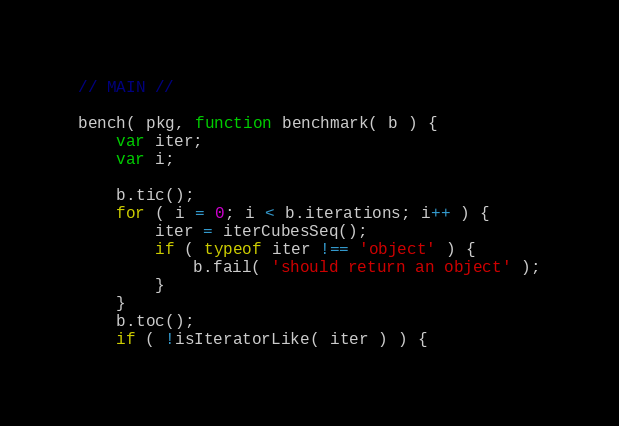<code> <loc_0><loc_0><loc_500><loc_500><_JavaScript_>

// MAIN //

bench( pkg, function benchmark( b ) {
	var iter;
	var i;

	b.tic();
	for ( i = 0; i < b.iterations; i++ ) {
		iter = iterCubesSeq();
		if ( typeof iter !== 'object' ) {
			b.fail( 'should return an object' );
		}
	}
	b.toc();
	if ( !isIteratorLike( iter ) ) {</code> 